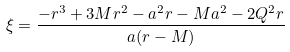Convert formula to latex. <formula><loc_0><loc_0><loc_500><loc_500>\xi = \frac { - r ^ { 3 } + 3 M r ^ { 2 } - a ^ { 2 } r - M a ^ { 2 } - 2 Q ^ { 2 } r } { a ( r - M ) }</formula> 